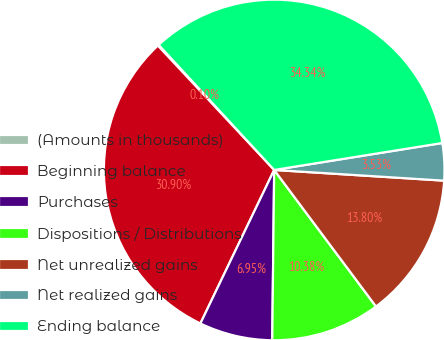<chart> <loc_0><loc_0><loc_500><loc_500><pie_chart><fcel>(Amounts in thousands)<fcel>Beginning balance<fcel>Purchases<fcel>Dispositions / Distributions<fcel>Net unrealized gains<fcel>Net realized gains<fcel>Ending balance<nl><fcel>0.1%<fcel>30.9%<fcel>6.95%<fcel>10.38%<fcel>13.8%<fcel>3.53%<fcel>34.34%<nl></chart> 